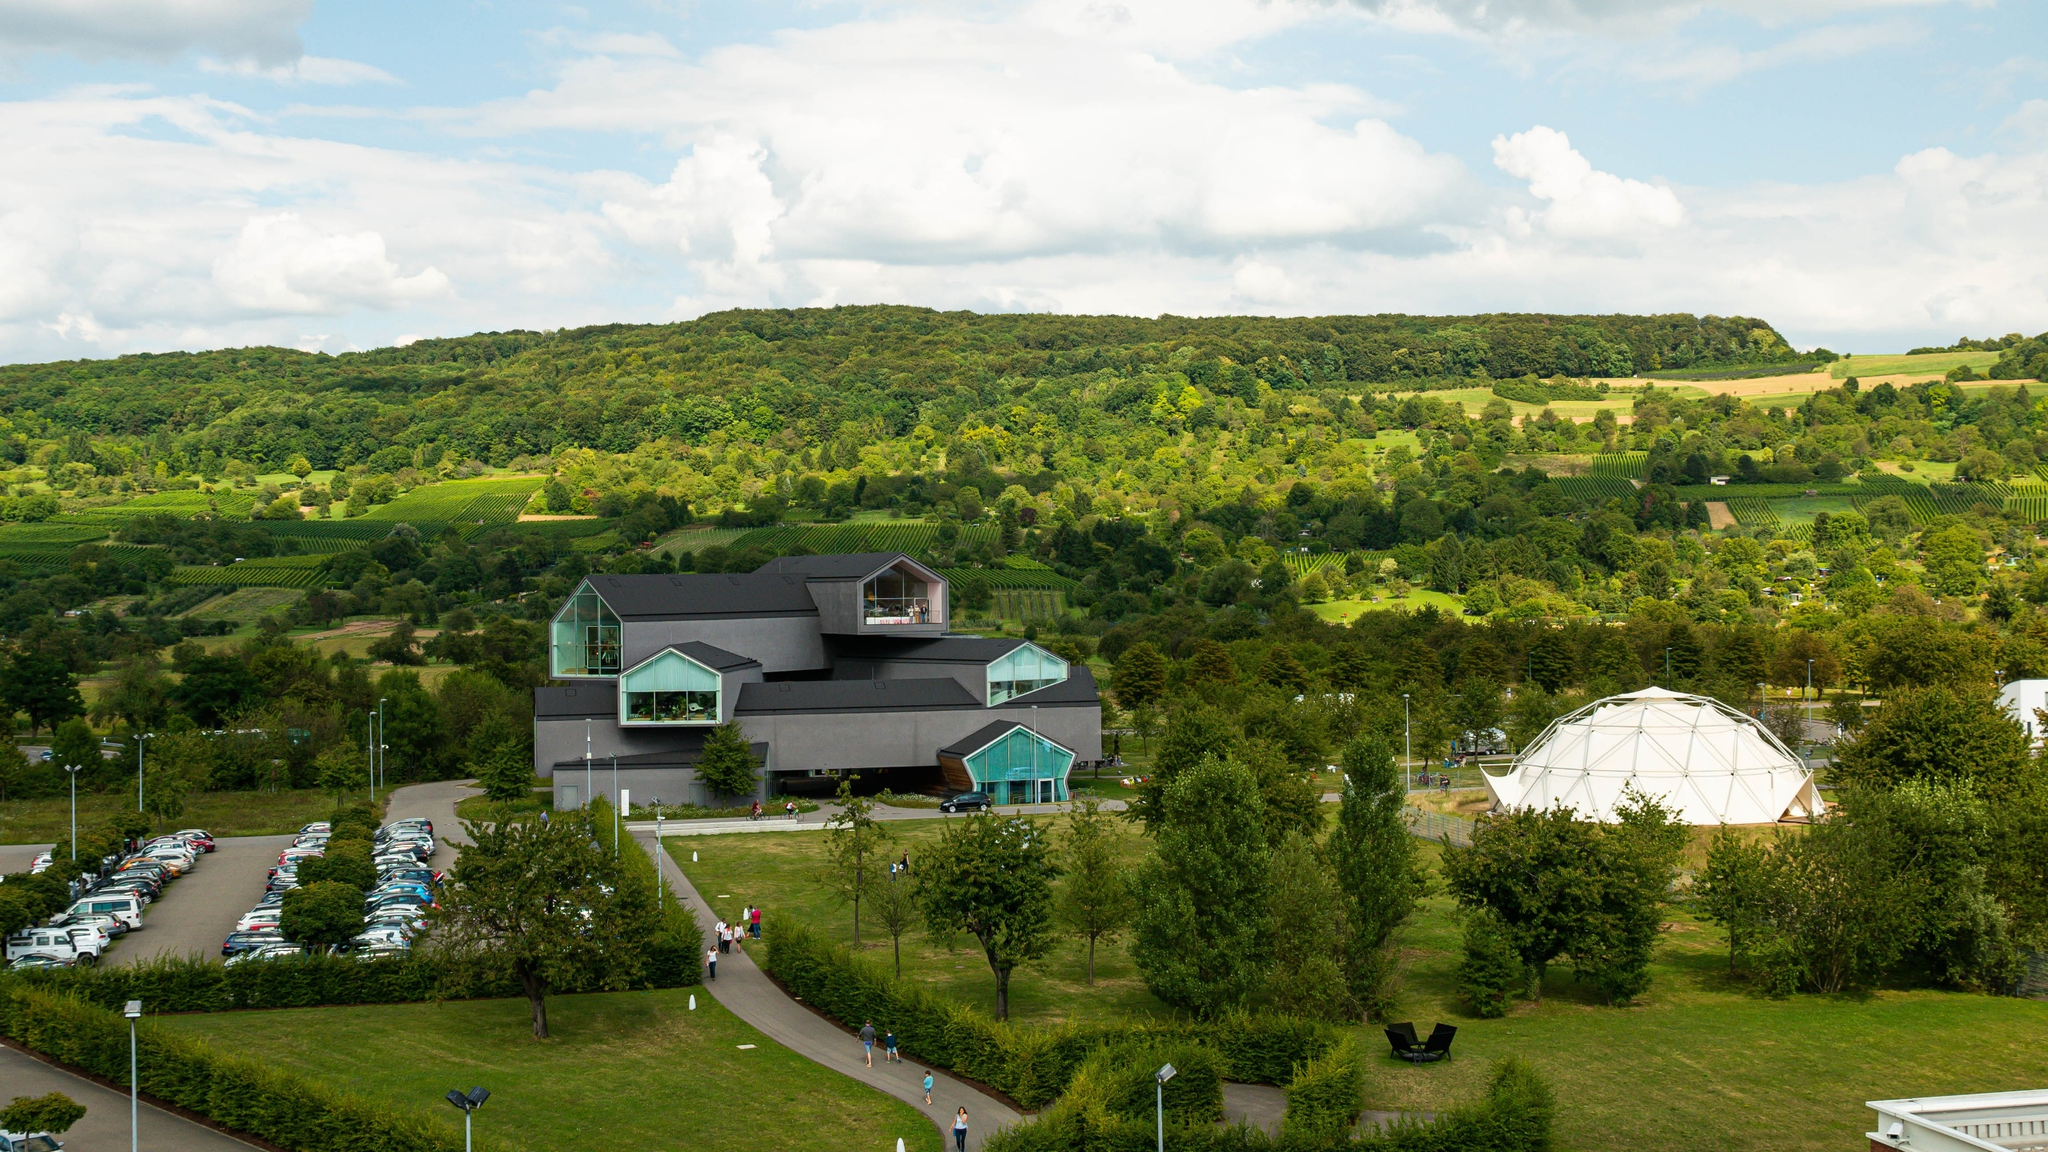Can you describe the surroundings of the museum? The surroundings of the Vitra Design Museum are lush and picturesque, characterized by rich greenery and rolling hills. Dense forests and well-maintained fields cover the hills, providing a beautiful natural backdrop. The area around the museum features a large, organized parking lot with several cars, indicating visitor accessibility. In addition to the modern architecture of the museum itself, there is also a striking geodesic dome structure nearby. The overall scenery is serene, combining architectural innovation with the tranquility of nature. 